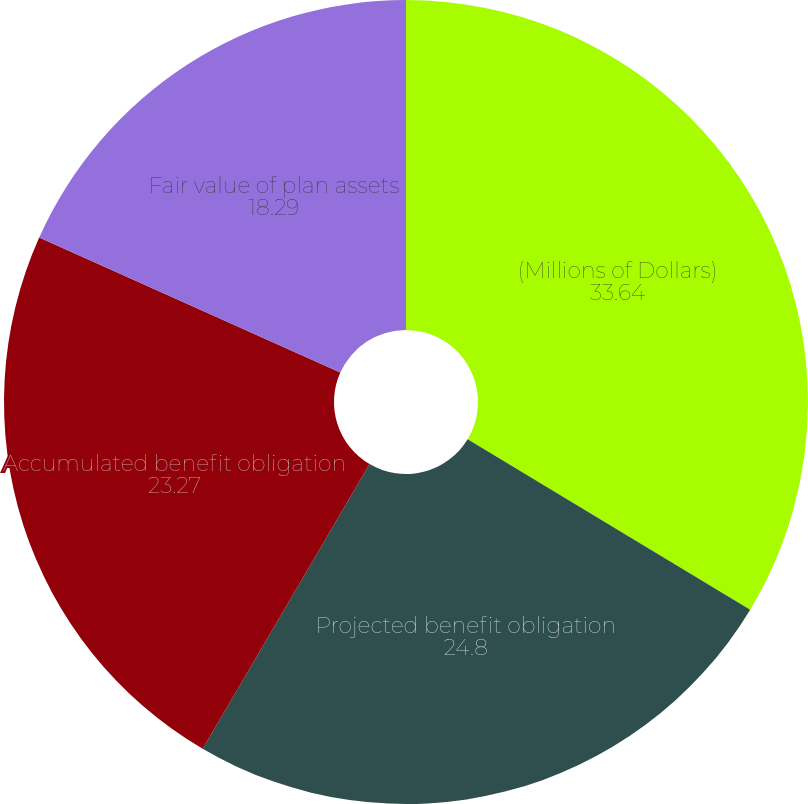Convert chart. <chart><loc_0><loc_0><loc_500><loc_500><pie_chart><fcel>(Millions of Dollars)<fcel>Projected benefit obligation<fcel>Accumulated benefit obligation<fcel>Fair value of plan assets<nl><fcel>33.64%<fcel>24.8%<fcel>23.27%<fcel>18.29%<nl></chart> 